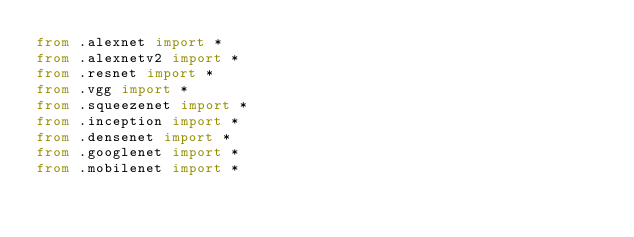<code> <loc_0><loc_0><loc_500><loc_500><_Python_>from .alexnet import *
from .alexnetv2 import *
from .resnet import *
from .vgg import *
from .squeezenet import *
from .inception import *
from .densenet import *
from .googlenet import *
from .mobilenet import *
</code> 